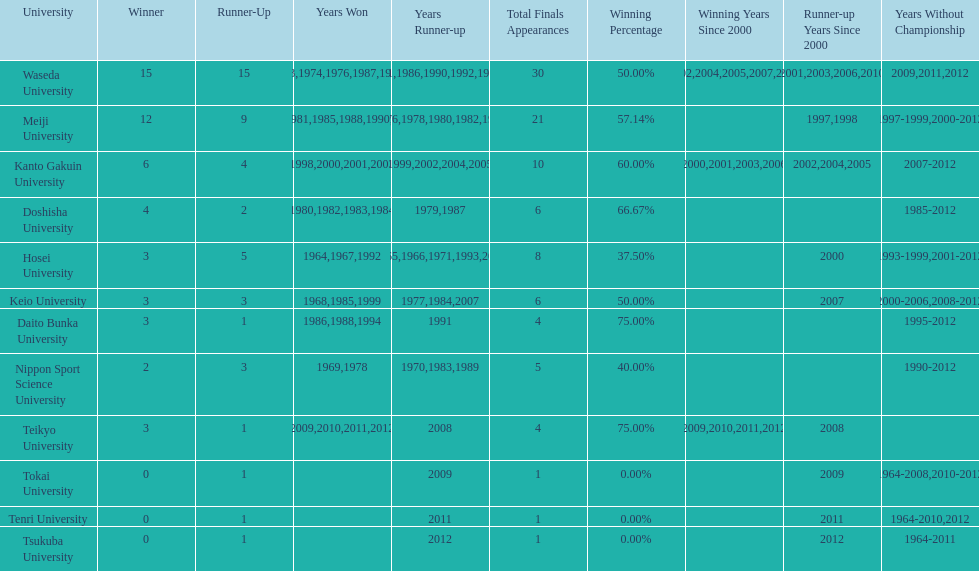Hosei won in 1964. who won the next year? Waseda University. 